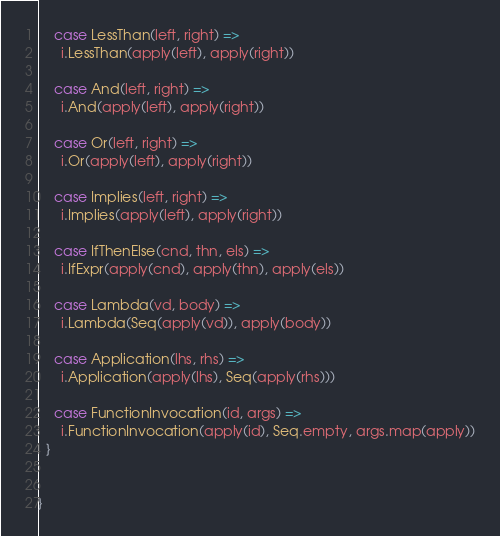<code> <loc_0><loc_0><loc_500><loc_500><_Scala_>    case LessThan(left, right) =>
      i.LessThan(apply(left), apply(right))

    case And(left, right) =>
      i.And(apply(left), apply(right))

    case Or(left, right) =>
      i.Or(apply(left), apply(right))

    case Implies(left, right) =>
      i.Implies(apply(left), apply(right))

    case IfThenElse(cnd, thn, els) =>
      i.IfExpr(apply(cnd), apply(thn), apply(els))

    case Lambda(vd, body) =>
      i.Lambda(Seq(apply(vd)), apply(body))

    case Application(lhs, rhs) =>
      i.Application(apply(lhs), Seq(apply(rhs)))

    case FunctionInvocation(id, args) =>
      i.FunctionInvocation(apply(id), Seq.empty, args.map(apply))
  }


}
</code> 